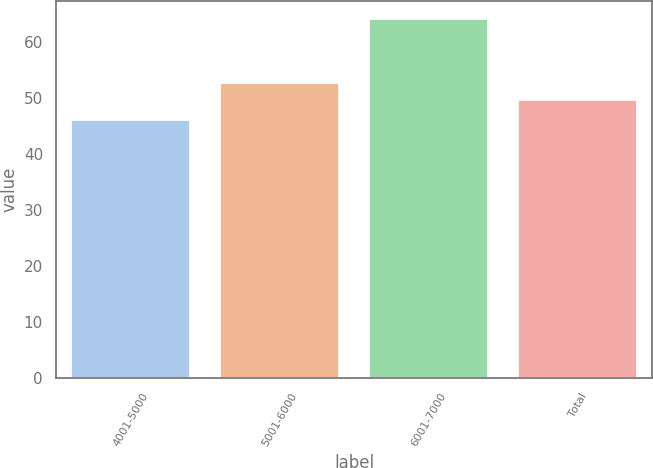<chart> <loc_0><loc_0><loc_500><loc_500><bar_chart><fcel>4001-5000<fcel>5001-6000<fcel>6001-7000<fcel>Total<nl><fcel>46.1<fcel>52.74<fcel>64.15<fcel>49.68<nl></chart> 